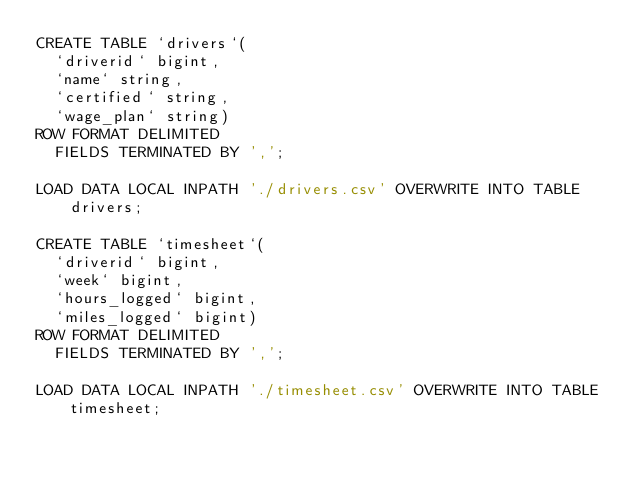<code> <loc_0><loc_0><loc_500><loc_500><_SQL_>CREATE TABLE `drivers`(
  `driverid` bigint,
  `name` string,
  `certified` string,
  `wage_plan` string)
ROW FORMAT DELIMITED
  FIELDS TERMINATED BY ',';

LOAD DATA LOCAL INPATH './drivers.csv' OVERWRITE INTO TABLE drivers;

CREATE TABLE `timesheet`(
  `driverid` bigint,
  `week` bigint,
  `hours_logged` bigint,
  `miles_logged` bigint)
ROW FORMAT DELIMITED
  FIELDS TERMINATED BY ',';

LOAD DATA LOCAL INPATH './timesheet.csv' OVERWRITE INTO TABLE timesheet;
</code> 